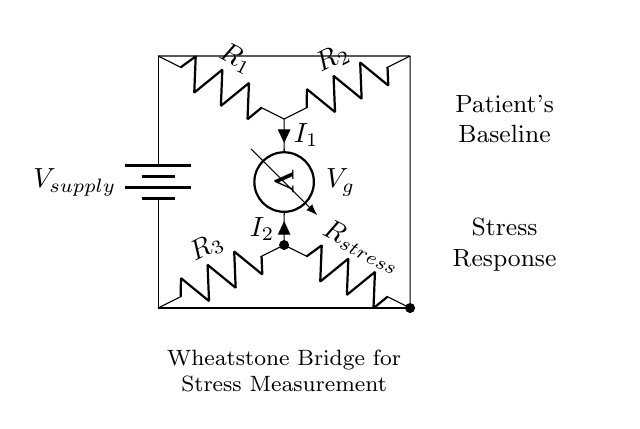What type of circuit is depicted here? This diagram represents a Wheatstone bridge, which is characterized by its four resistors, and is used for measuring unknown resistances by balancing two legs of a bridge circuit.
Answer: Wheatstone bridge What are the names of the resistors in this circuit? The resistors are labeled as R1, R2, R3, and Rstress, which differentiate their placement and function within the circuit.
Answer: R1, R2, R3, Rstress What is the function of the voltmeter? The voltmeter is used to measure the potential difference (voltage) across the resistor Rstress, providing an indication of the stress level by sensing changes during therapy.
Answer: Measure voltage What is the current flowing through the branch with Rstress called? The current flowing through the Rstress branch is labeled as I2 in the circuit diagram, indicating its relation to the stress measurement.
Answer: I2 How does Rstress relate to the stress levels of the patient? Rstress is variable and changes with the patient's stress level; as the patient's stress changes, it alters the resistance, affecting the voltage detected by the voltmeter in the bridge circuit.
Answer: It varies with stress levels What is the purpose of adjusting R1 and R2 in this circuit? R1 and R2 can be adjusted to balance the bridge; achieving balance allows for accurate measurement of the unknown resistance, Rstress, enabling precise stress assessment.
Answer: To balance the bridge What does Vg measure in this circuit? Vg measures the voltage difference across the two junctions of the resistors, which indicates the balance of the Wheatstone bridge and the value of Rstress in response to the patient's stress.
Answer: Voltage across Rstress 